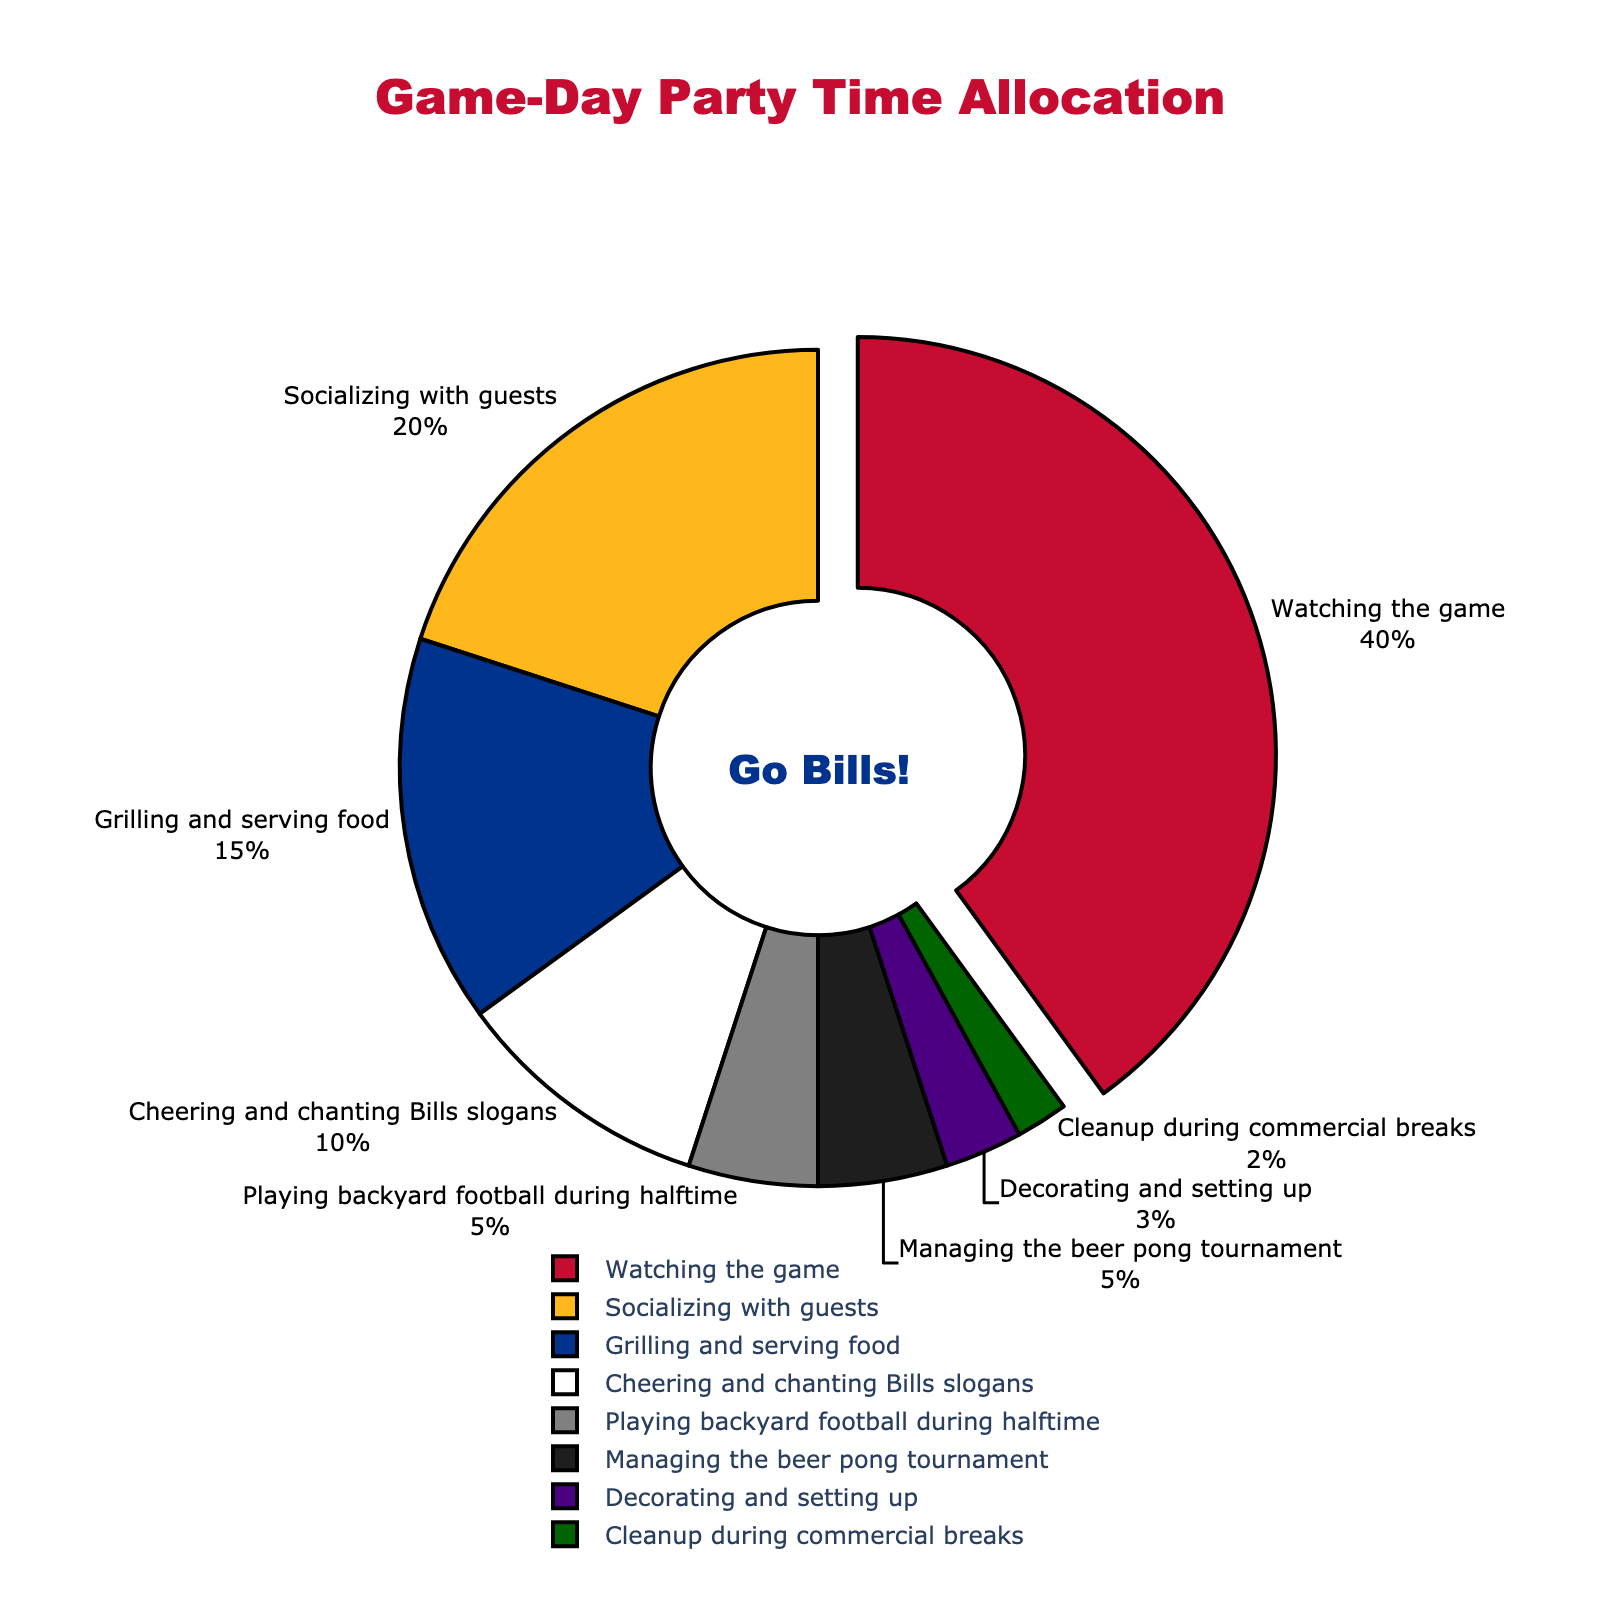What's the activity that takes the largest percentage of time during a game-day party? Watching the game has the largest percentage as indicated by a segment pulled out from the pie chart with 40% allocated time.
Answer: Watching the game Which two activities occupy equal time percentages? Playing backyard football during halftime and managing the beer pong tournament both have equal time percentages of 5%, as indicated by the segments of equal sizes.
Answer: Playing backyard football during halftime, Managing the beer pong tournament What's the total time percentage spent on socializing with guests and grilling and serving food? Socializing with guests takes 20% and grilling and serving food takes 15%. The total time percentage is 20% + 15% = 35%.
Answer: 35% Is the time spent socializing with guests greater than the time spent cheering and chanting Bills slogans? Socializing with guests takes 20%, while cheering and chanting Bills slogans takes 10%. Therefore, socializing with guests takes more time.
Answer: Yes What percentage of time is spent on activities other than watching the game and socializing with guests? Watching the game takes 40% and socializing with guests takes 20%. The total of these two main activities is 60%. So, the percentage of time spent on other activities is 100% - 60% = 40%.
Answer: 40% Which activity has the least allocated time, and what is that time percentage? Cleanup during commercial breaks has the least allocated time, occupying only 2% as shown by the smallest segment in the pie chart.
Answer: Cleanup during commercial breaks, 2% Compare the time allocated for managing the beer pong tournament with the time for decorating and setting up. Managing the beer pong tournament occupies 5%, while decorating and setting up occupies 3%. Therefore, more time is allocated to managing the beer pong tournament.
Answer: Managing the beer pong tournament What's the average time percentage of grilling and serving food, cheering and chanting Bills slogans, and decorating and setting up? Average = (Time percentage of grilling and serving food + Time percentage of cheering and chanting Bills slogans + Time percentage of decorating and setting up) / 3 = (15% + 10% + 3%) / 3 = 28% / 3 = 9.33%.
Answer: 9.33% What is the combined time percentage spent on playing backyard football during halftime and managing the beer pong tournament? Playing backyard football during halftime takes 5% and managing the beer pong tournament takes another 5%. The combined time percentage is 5% + 5% = 10%.
Answer: 10% 